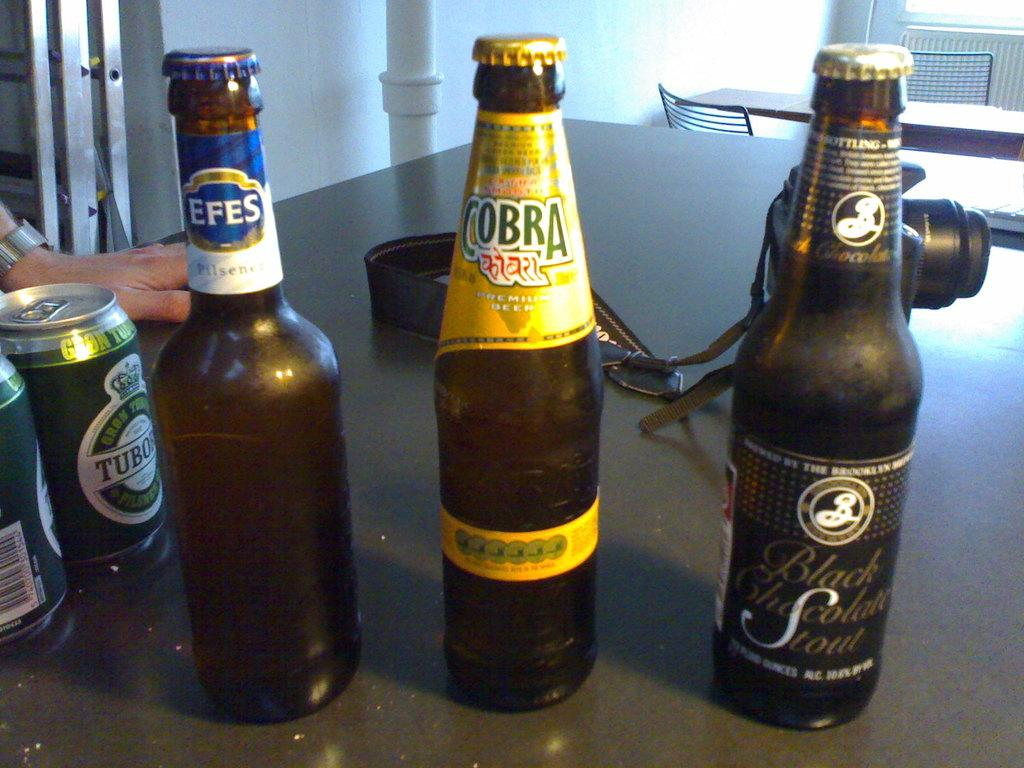<image>
Create a compact narrative representing the image presented. Efes, Cobra and Black Chocolate Stout are branded on these three bottles. 